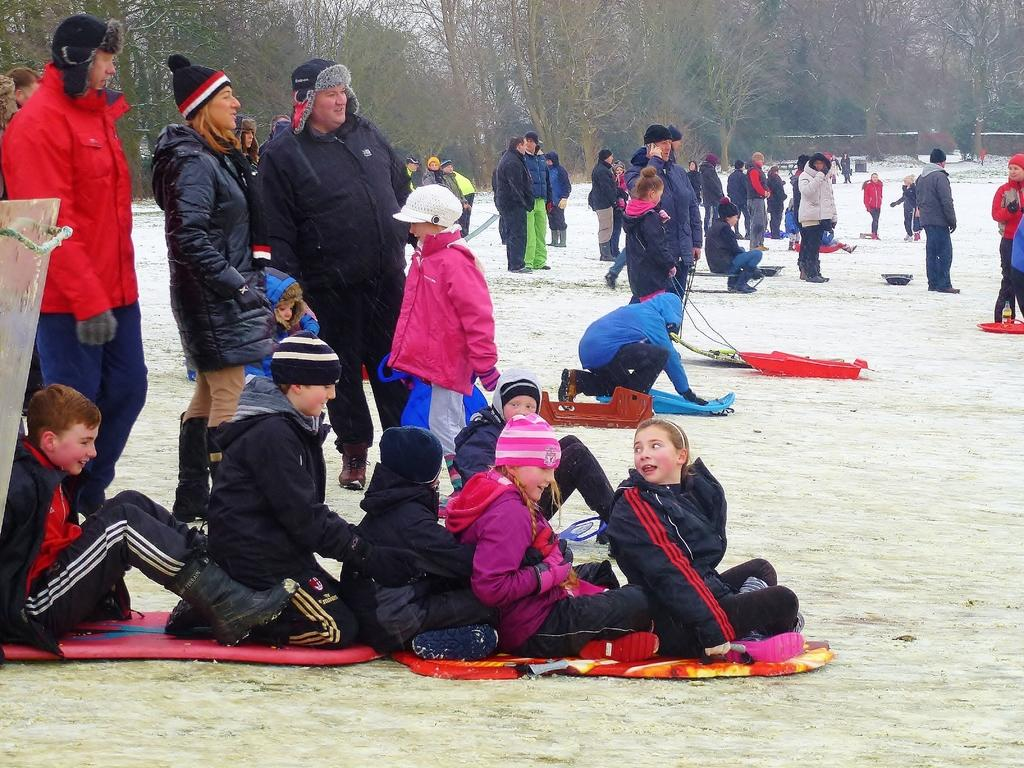How many people are in the image? There is a group of people in the image, but the exact number is not specified. What are the people in the image doing? Some people are seated, while others are standing. What are the people wearing in the image? The people are wearing sweaters. What can be seen in the background of the image? There are trees in the background of the image. What type of knowledge is being shared among the people in the image? There is no indication in the image of any knowledge being shared among the people. 